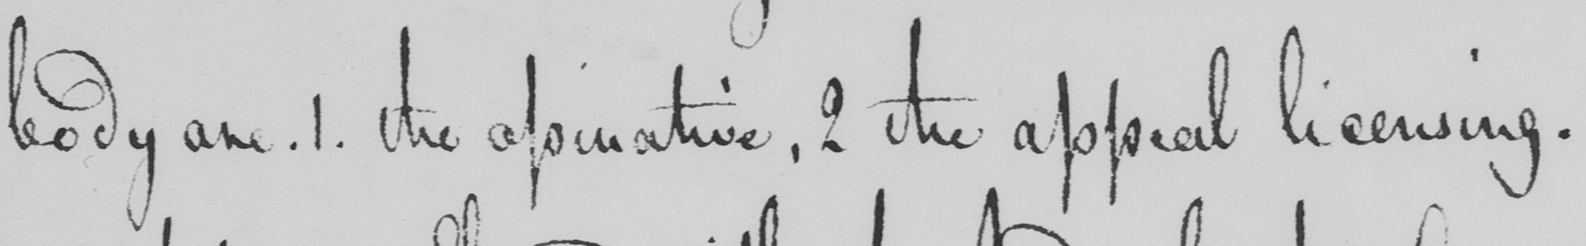What does this handwritten line say? body are . 1 . the apinative , 2 the appeal licensing . 